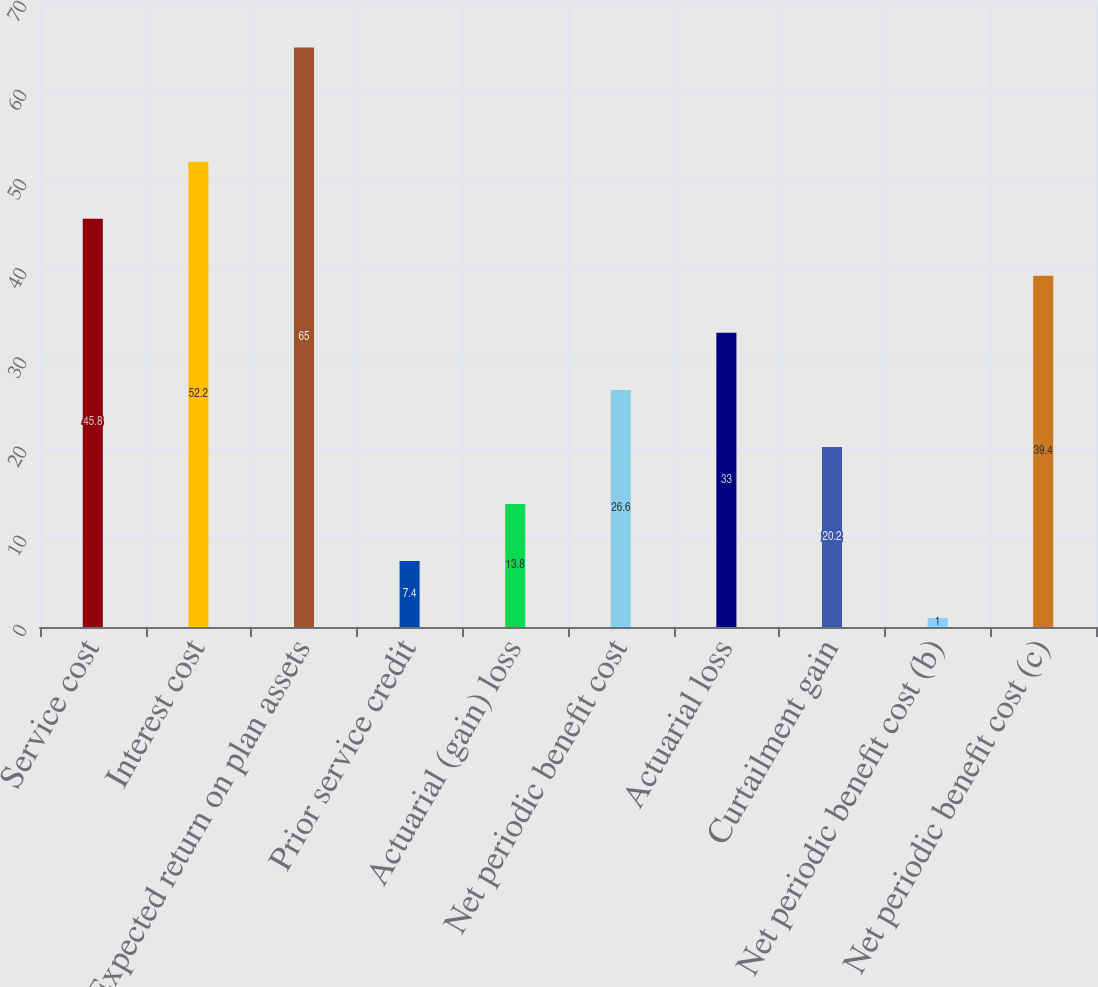Convert chart to OTSL. <chart><loc_0><loc_0><loc_500><loc_500><bar_chart><fcel>Service cost<fcel>Interest cost<fcel>Expected return on plan assets<fcel>Prior service credit<fcel>Actuarial (gain) loss<fcel>Net periodic benefit cost<fcel>Actuarial loss<fcel>Curtailment gain<fcel>Net periodic benefit cost (b)<fcel>Net periodic benefit cost (c)<nl><fcel>45.8<fcel>52.2<fcel>65<fcel>7.4<fcel>13.8<fcel>26.6<fcel>33<fcel>20.2<fcel>1<fcel>39.4<nl></chart> 